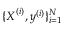Convert formula to latex. <formula><loc_0><loc_0><loc_500><loc_500>\{ \boldsymbol X ^ { ( i ) } , \boldsymbol y ^ { ( i ) } \} _ { i = 1 } ^ { N }</formula> 